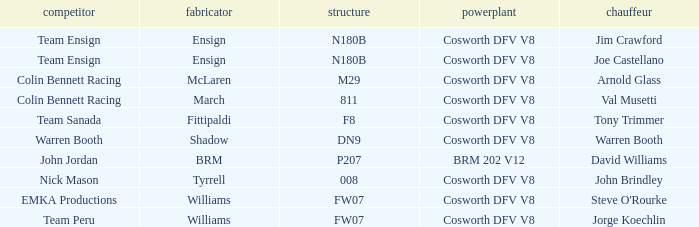What engine is used by Colin Bennett Racing with an 811 chassis? Cosworth DFV V8. 